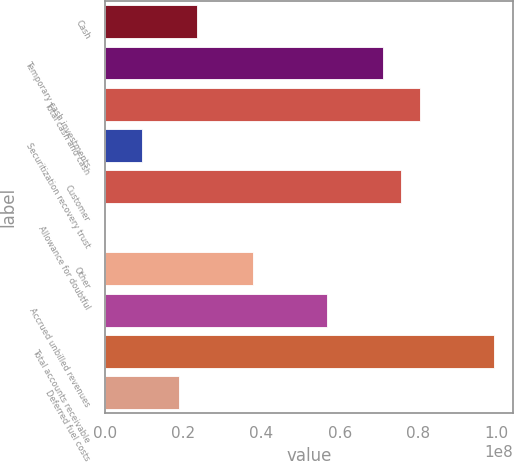<chart> <loc_0><loc_0><loc_500><loc_500><bar_chart><fcel>Cash<fcel>Temporary cash investments<fcel>Total cash and cash<fcel>Securitization recovery trust<fcel>Customer<fcel>Allowance for doubtful<fcel>Other<fcel>Accrued unbilled revenues<fcel>Total accounts receivable<fcel>Deferred fuel costs<nl><fcel>2.36797e+07<fcel>7.09706e+07<fcel>8.04287e+07<fcel>9.49248e+06<fcel>7.56996e+07<fcel>34311<fcel>3.7867e+07<fcel>5.67833e+07<fcel>9.9345e+07<fcel>1.89506e+07<nl></chart> 